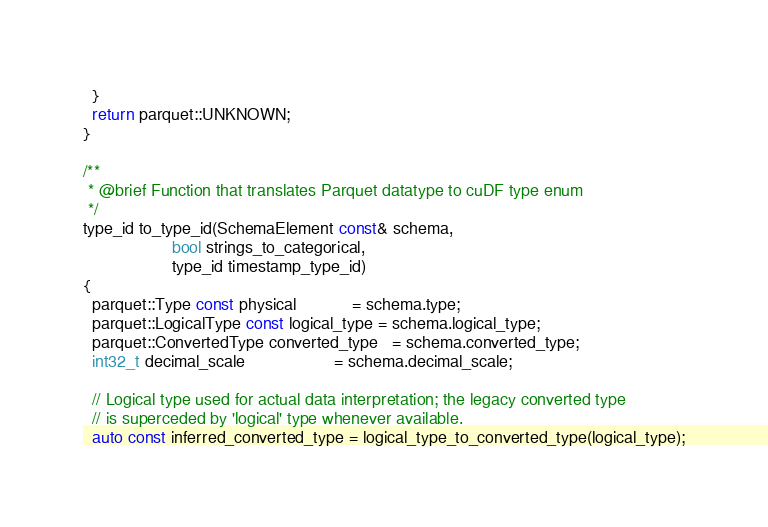<code> <loc_0><loc_0><loc_500><loc_500><_Cuda_>  }
  return parquet::UNKNOWN;
}

/**
 * @brief Function that translates Parquet datatype to cuDF type enum
 */
type_id to_type_id(SchemaElement const& schema,
                   bool strings_to_categorical,
                   type_id timestamp_type_id)
{
  parquet::Type const physical            = schema.type;
  parquet::LogicalType const logical_type = schema.logical_type;
  parquet::ConvertedType converted_type   = schema.converted_type;
  int32_t decimal_scale                   = schema.decimal_scale;

  // Logical type used for actual data interpretation; the legacy converted type
  // is superceded by 'logical' type whenever available.
  auto const inferred_converted_type = logical_type_to_converted_type(logical_type);</code> 